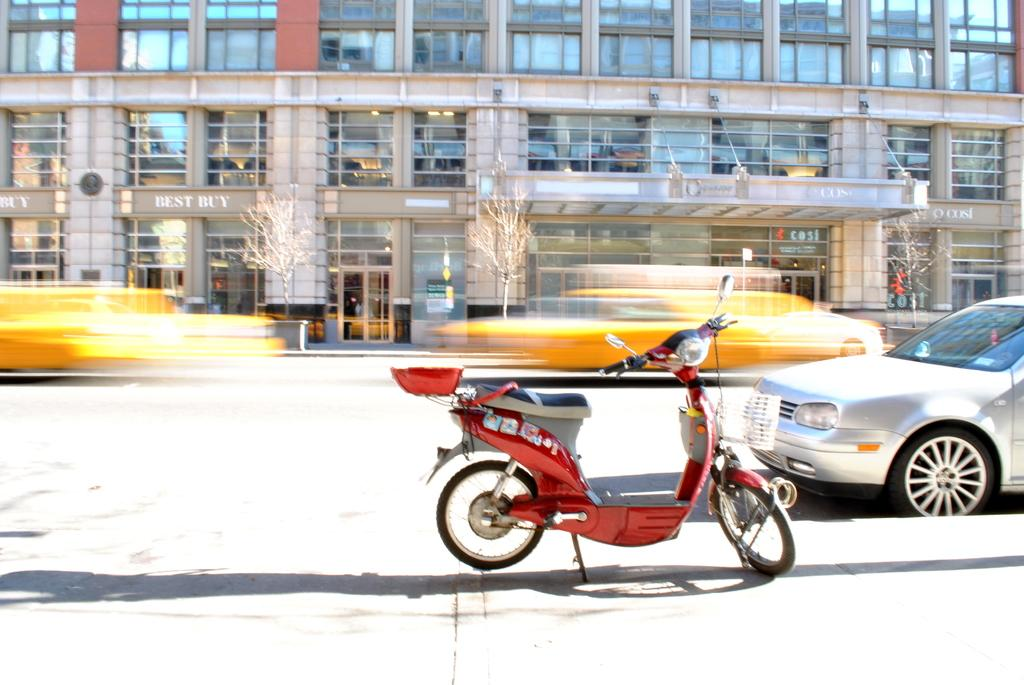What can be seen in the foreground of the image? There are vehicles visible on the road in the foreground of the image. What is located at the top of the image? There is a building at the top of the image. What type of vegetation is visible in front of the building? Trees are visible in front of the building. What type of harmony is being played by the trees in the image? There is no indication of music or harmony in the image; it features vehicles, a building, and trees. What thought is being expressed by the building in the image? Buildings do not express thoughts; they are inanimate structures. 